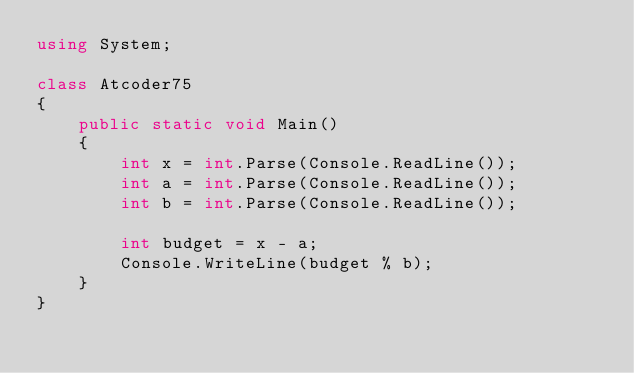<code> <loc_0><loc_0><loc_500><loc_500><_C#_>using System;

class Atcoder75
{
    public static void Main()
    {
        int x = int.Parse(Console.ReadLine());
        int a = int.Parse(Console.ReadLine());
        int b = int.Parse(Console.ReadLine());

        int budget = x - a;
        Console.WriteLine(budget % b);
    }
}</code> 